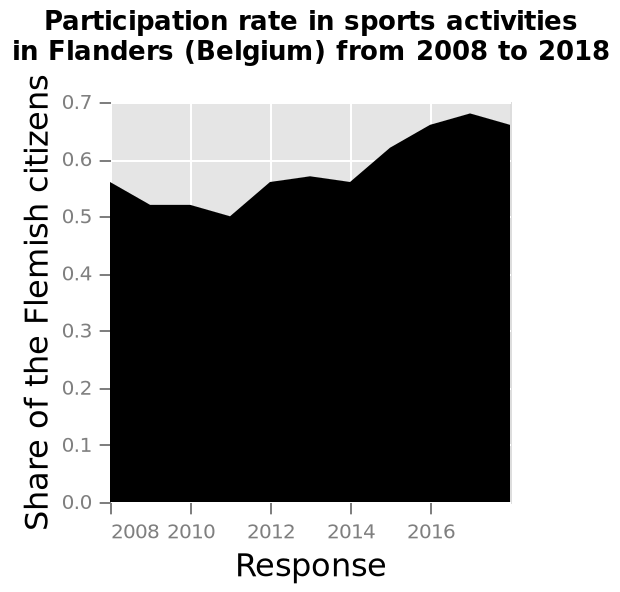<image>
What does the y-axis on the area graph measure? The y-axis measures the "Share of the Flemish citizens". 